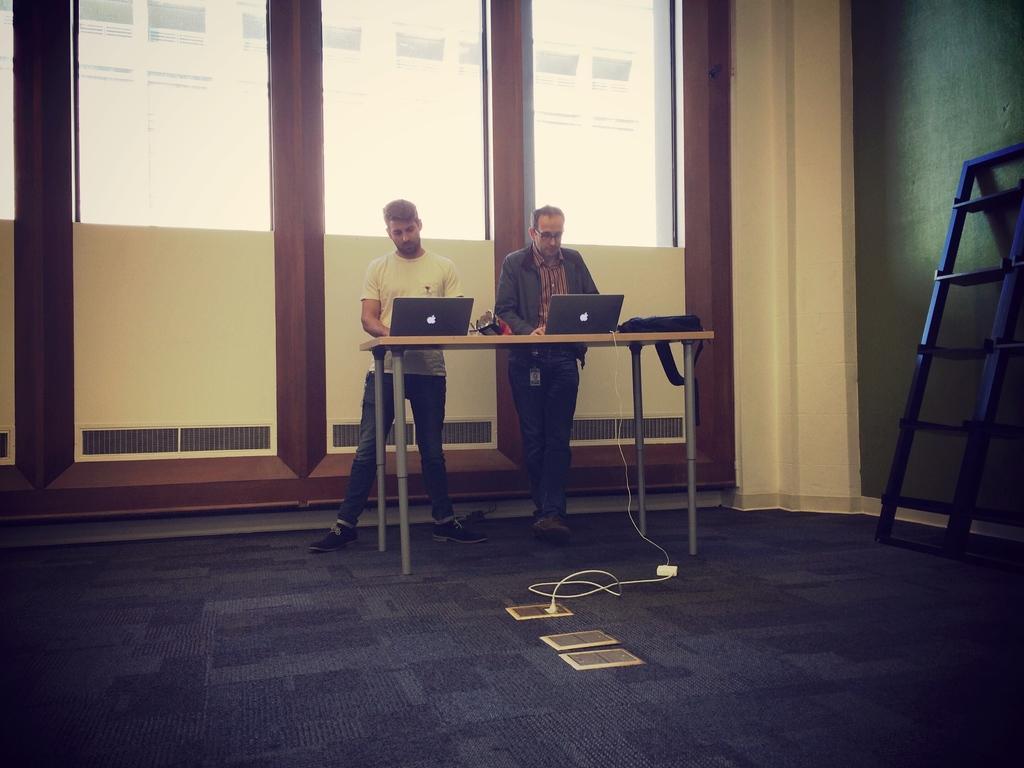Please provide a concise description of this image. In this picture there are two men standing at the table and working on the laptop. On the front bottom side there is a flooring mat with cables and extension box. In the background there is a big glass wall. 